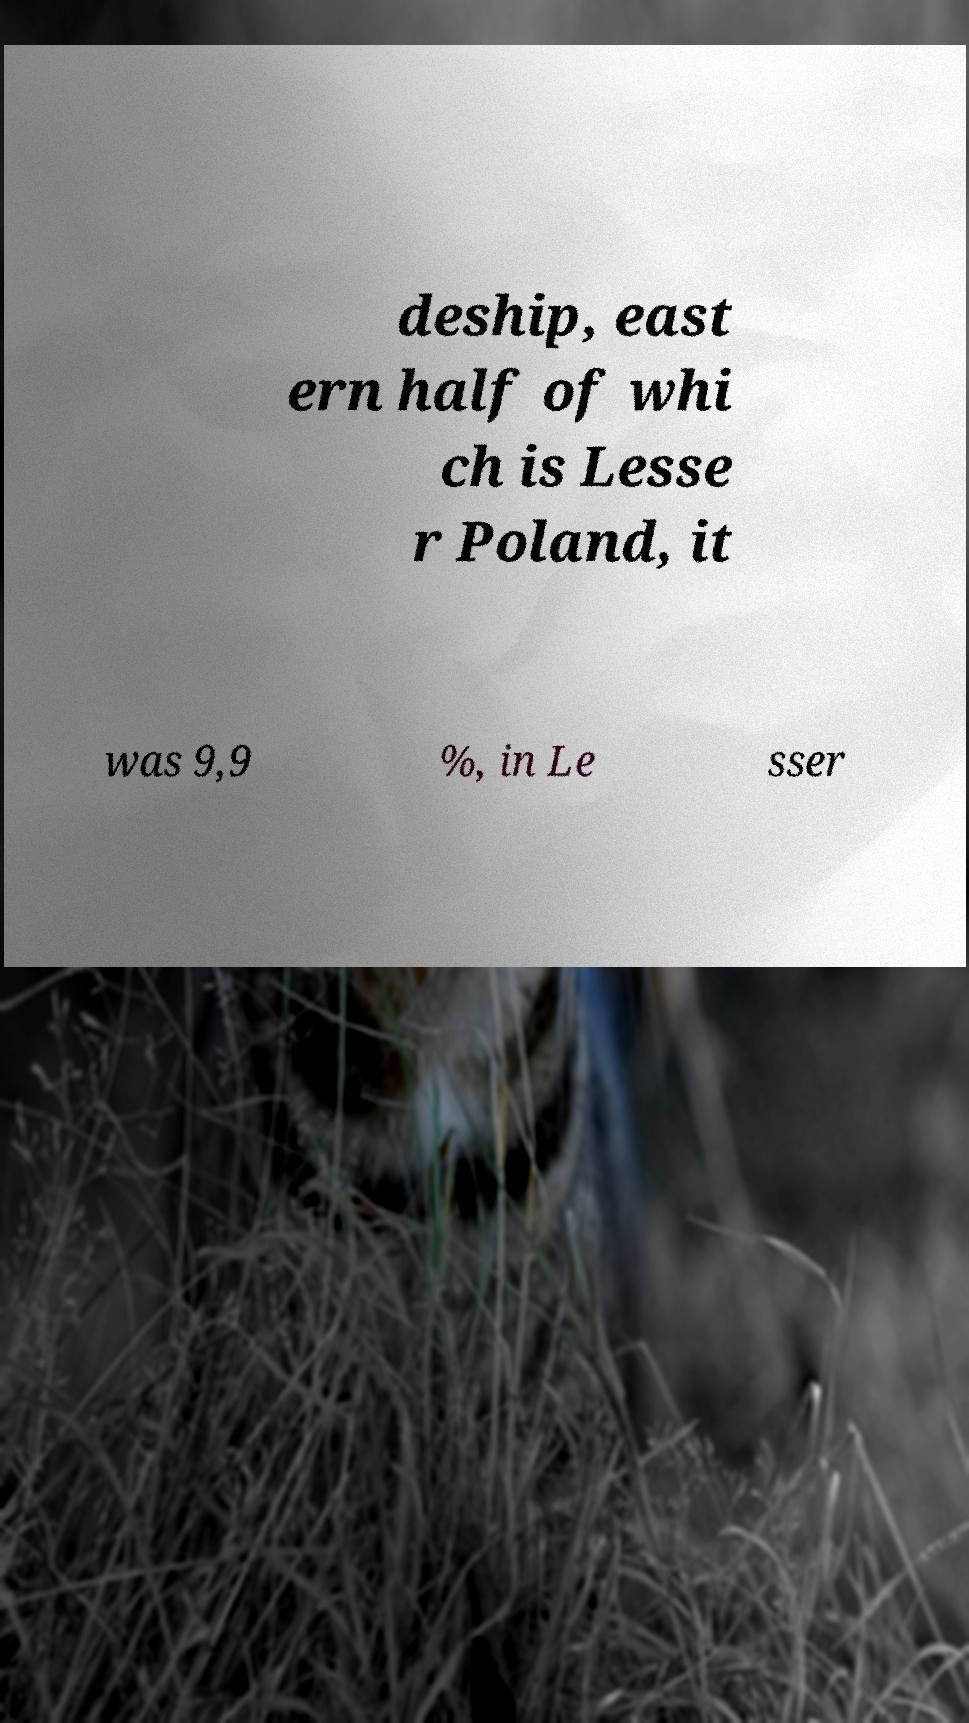Please identify and transcribe the text found in this image. deship, east ern half of whi ch is Lesse r Poland, it was 9,9 %, in Le sser 